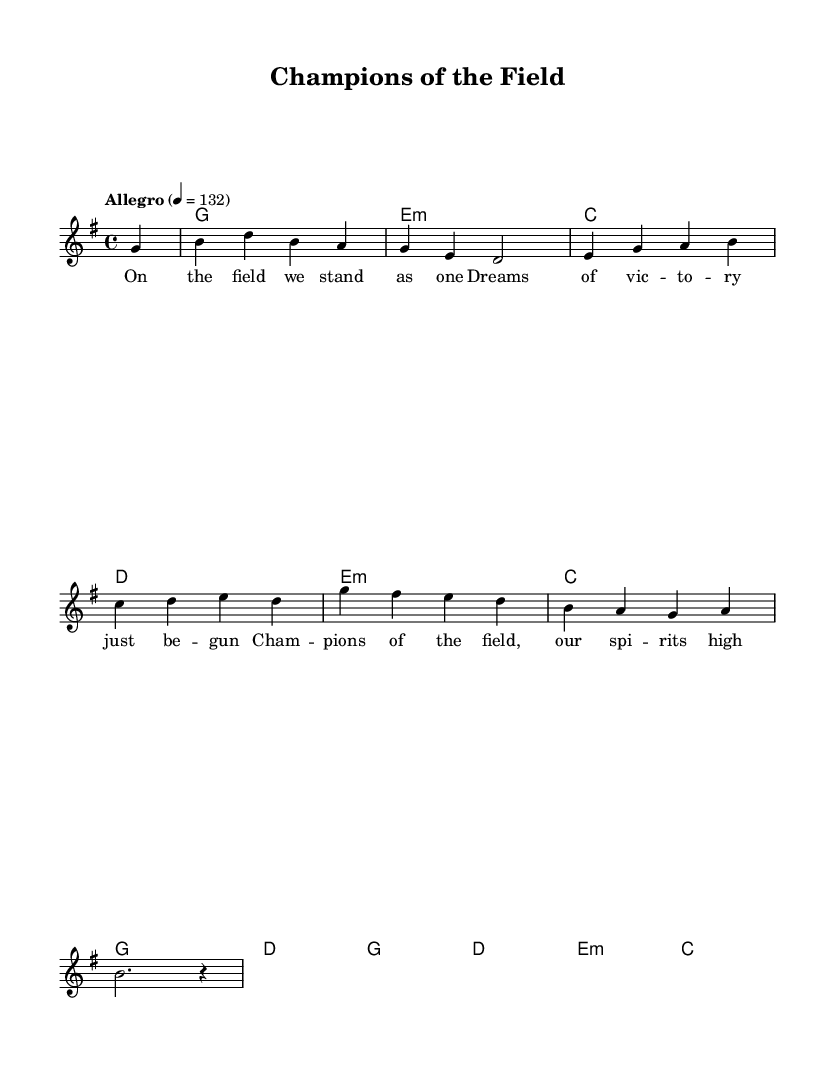What is the key signature of this music? The key signature is determined by the presence of sharps or flats in the piece. In this case, there are no sharps or flats indicated, so it is G major, which has one sharp (F#).
Answer: G major What is the time signature of this music? The time signature is specified at the beginning of the music and is represented as a fraction. Here, it is 4/4, which means there are four beats in a measure and the quarter note gets one beat.
Answer: 4/4 What is the tempo marking for this piece? The tempo marking is indicated in the score, specifying the speed of the music. In this score, it states "Allegro" with a metronome marking of 132 beats per minute, indicating a fast tempo.
Answer: Allegro 4 = 132 How many measures are shown in the melody? To find the number of measures, count the vertical barlines that separate the sections in the melody. In this score, there are 8 measures present.
Answer: 8 What type of chord is the harmony on the first measure? The chord designation for the first measure is written in chord names and indicates a G major chord, as it corresponds to the "g1" notation.
Answer: G What is the theme of the lyrics in this piece? The lyrics provide a direct description of the context; they emphasize unity and the spirit of victory on the athletic field. This theme of celebrating athletic achievements is evident throughout the lyrics.
Answer: Champions of the field Which instrument is primarily featured in the melody? The melody is written for a voice part, as indicated by the "Voice = 'lead'" label, suggesting that it is meant to be sung rather than played by an instrument.
Answer: Voice 